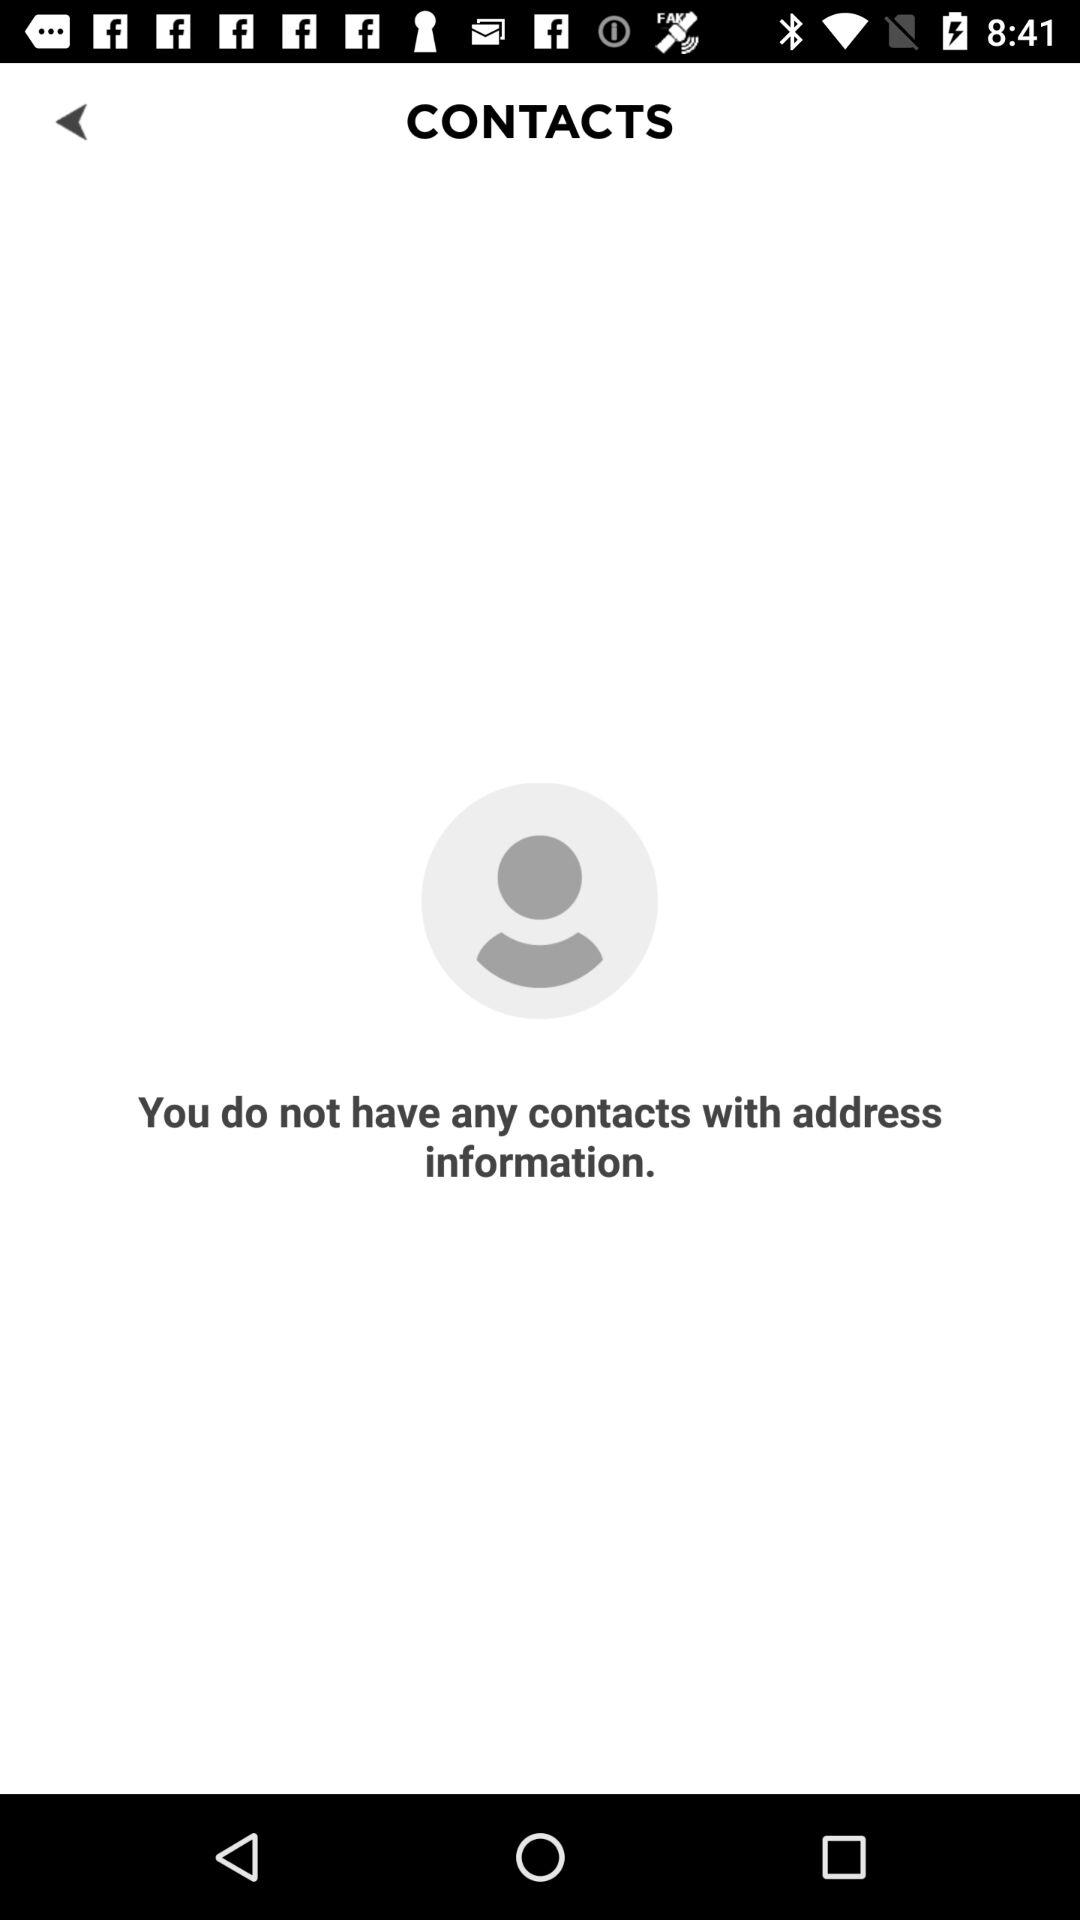Is there any contact list?
When the provided information is insufficient, respond with <no answer>. <no answer> 